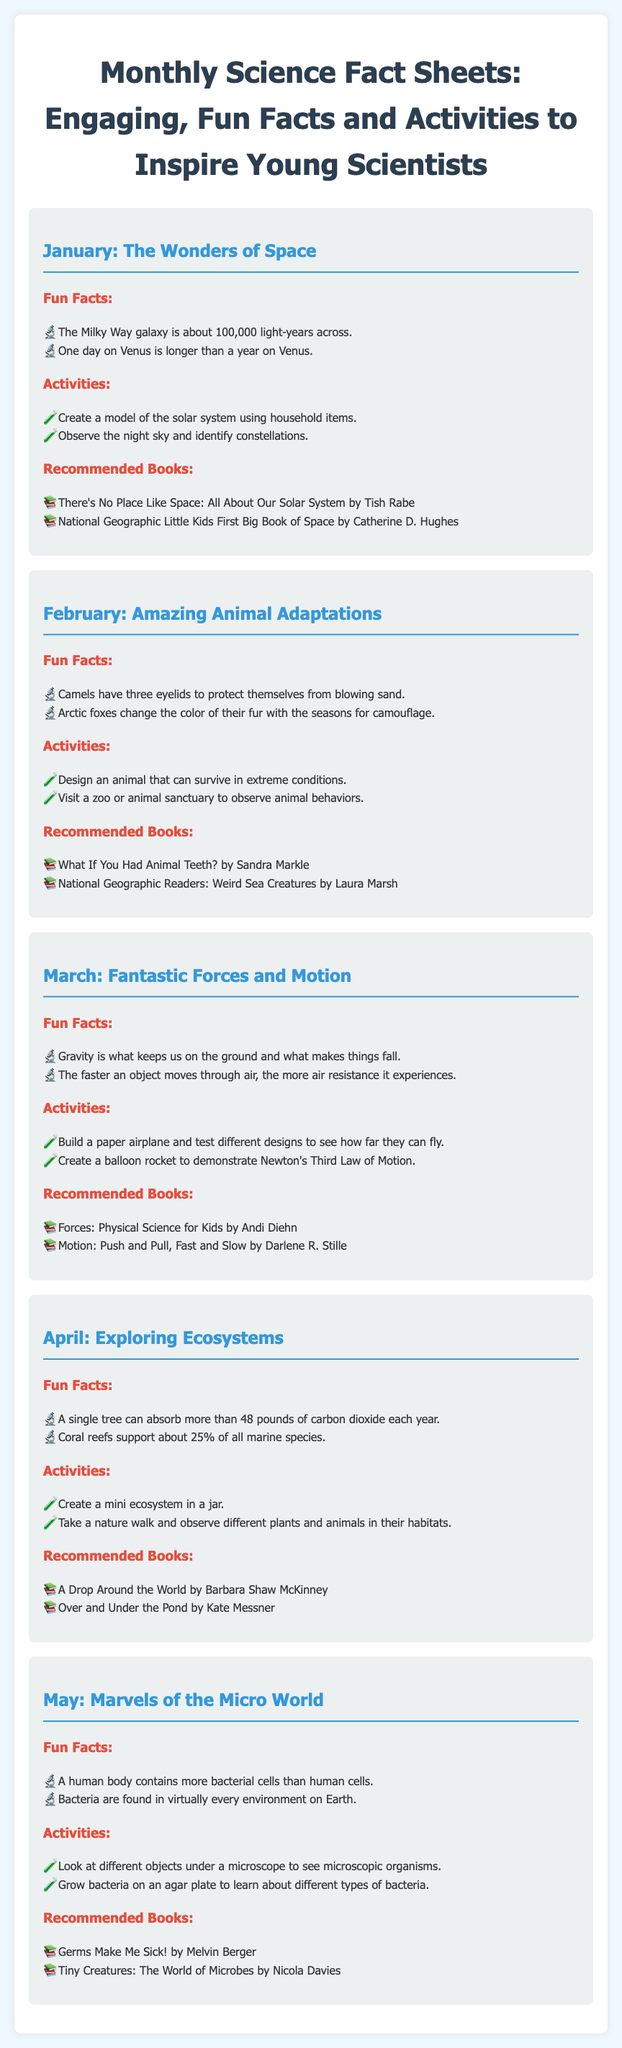What is the theme for January? The theme for January is "The Wonders of Space."
Answer: The Wonders of Space How many eyelids do camels have? The fact states that camels have three eyelids.
Answer: Three What is one activity for March? The document lists activities, including building a paper airplane.
Answer: Build a paper airplane Which book is recommended for April? The recommended book for April includes "A Drop Around the World."
Answer: A Drop Around the World How many fun facts are provided for February? The section gives two fun facts about animal adaptations.
Answer: Two What can a single tree absorb per year? The document mentions that a single tree can absorb more than 48 pounds of carbon dioxide.
Answer: More than 48 pounds Which month discusses bacteria? The month discussing bacteria is May.
Answer: May What type of organisms can be viewed under a microscope in the May activities? The activities mention looking at different objects to see microscopic organisms.
Answer: Microscopic organisms What is the main subject of the document? The document provides fact sheets full of engaging science facts and activities for young scientists.
Answer: Science fact sheets 